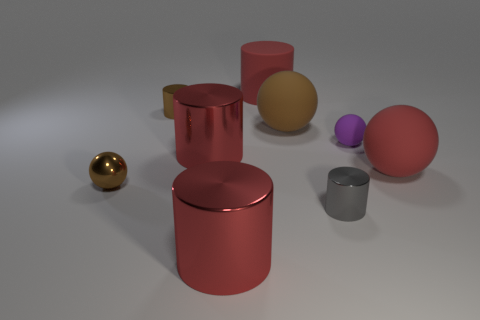Can you describe the different colors of the objects and their arrangement? Certainly! The objects present a variety of colors: there's a large brown cylinder, a golden sphere, a smaller purple sphere, a red cylinder, a pink cube, and a small silver cylinder. They are arranged in no particular order, scattered across a light surface, which gives the ensemble a casual yet visually interesting composition. 